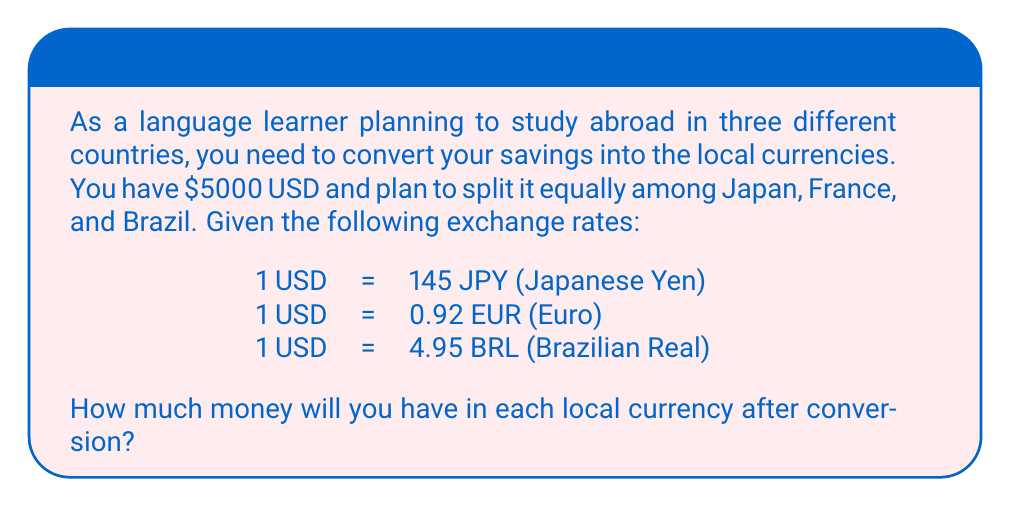Help me with this question. Let's approach this problem step-by-step:

1. Calculate the amount to be converted for each country:
   $\frac{5000}{3} = 1666.67$ USD per country

2. Convert to Japanese Yen (JPY):
   $1666.67 \times 145 = 241,667.15$ JPY

3. Convert to Euro (EUR):
   $1666.67 \times 0.92 = 1,533.34$ EUR

4. Convert to Brazilian Real (BRL):
   $1666.67 \times 4.95 = 8,250.02$ BRL

5. Round all results to two decimal places for currency:
   JPY: 241,667.15 ≈ 241,667.15 (no change needed)
   EUR: 1,533.34 ≈ 1,533.34 (no change needed)
   BRL: 8,250.02 ≈ 8,250.02 (no change needed)

Therefore, after conversion, you will have:
- 241,667.15 JPY in Japan
- 1,533.34 EUR in France
- 8,250.02 BRL in Brazil
Answer: 241,667.15 JPY, 1,533.34 EUR, 8,250.02 BRL 